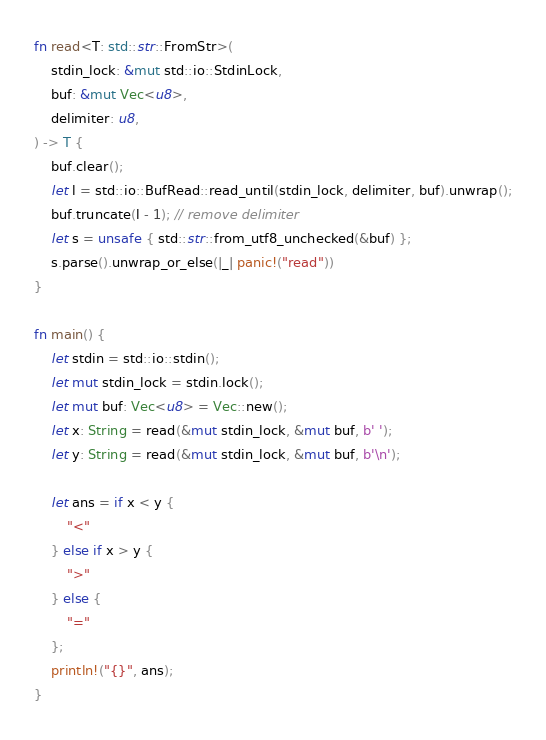<code> <loc_0><loc_0><loc_500><loc_500><_Rust_>fn read<T: std::str::FromStr>(
    stdin_lock: &mut std::io::StdinLock,
    buf: &mut Vec<u8>,
    delimiter: u8,
) -> T {
    buf.clear();
    let l = std::io::BufRead::read_until(stdin_lock, delimiter, buf).unwrap();
    buf.truncate(l - 1); // remove delimiter
    let s = unsafe { std::str::from_utf8_unchecked(&buf) };
    s.parse().unwrap_or_else(|_| panic!("read"))
}

fn main() {
    let stdin = std::io::stdin();
    let mut stdin_lock = stdin.lock();
    let mut buf: Vec<u8> = Vec::new();
    let x: String = read(&mut stdin_lock, &mut buf, b' ');
    let y: String = read(&mut stdin_lock, &mut buf, b'\n');

    let ans = if x < y {
        "<"
    } else if x > y {
        ">"
    } else {
        "="
    };
    println!("{}", ans);
}
</code> 